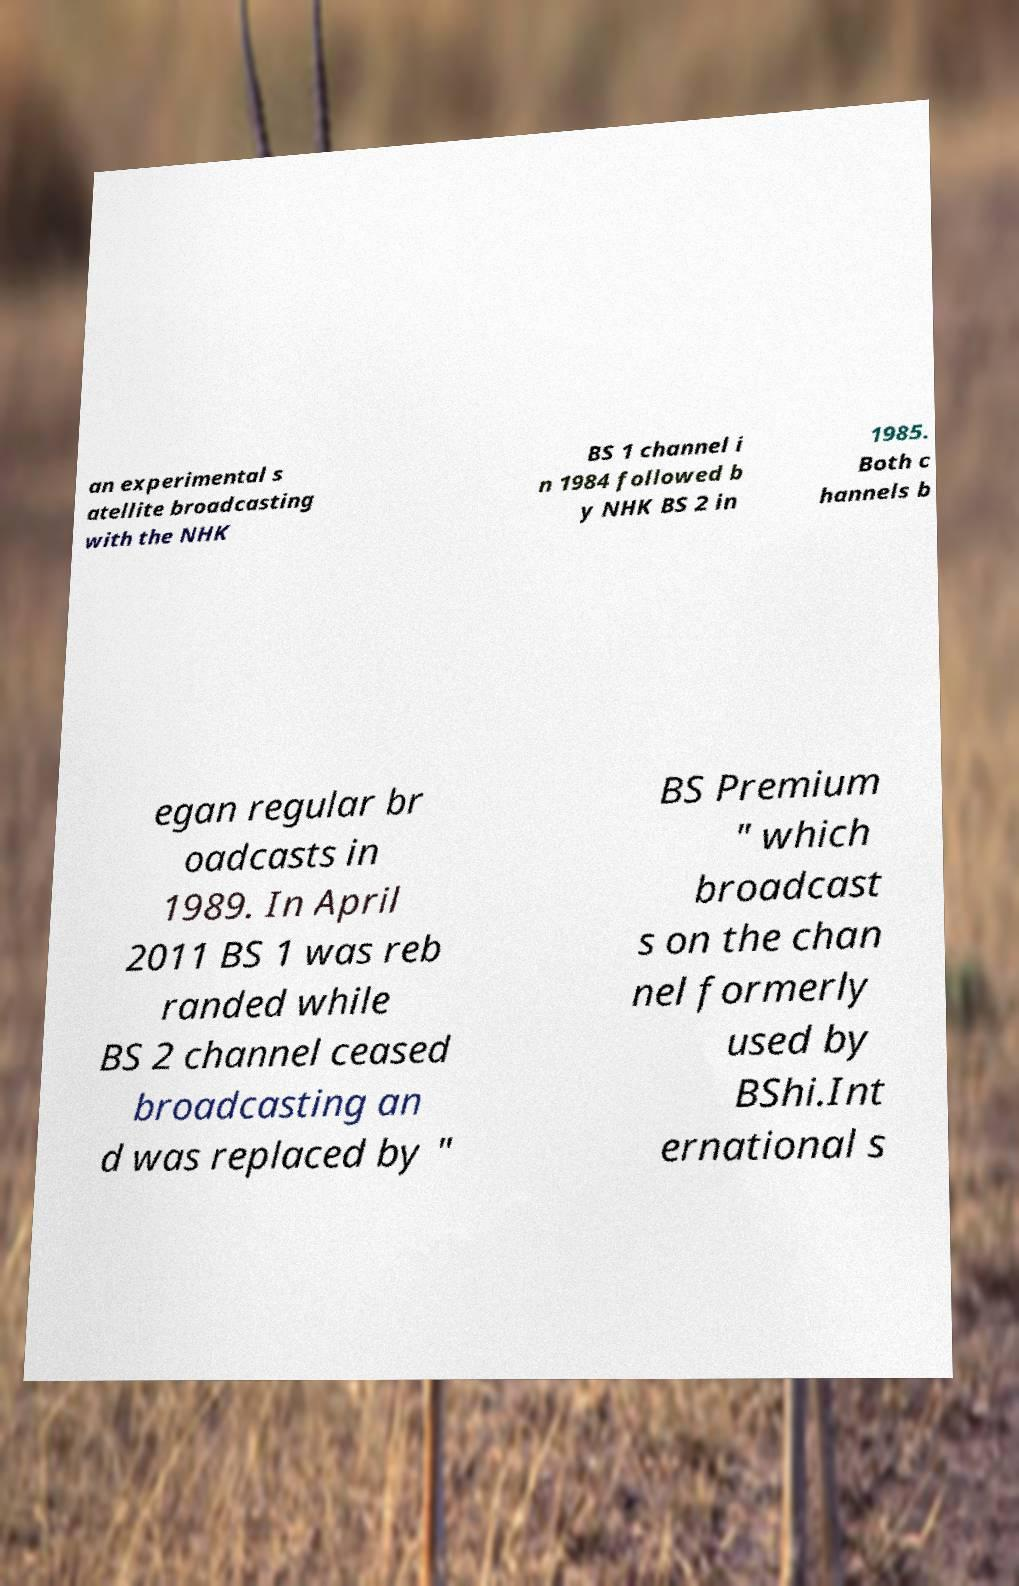Could you assist in decoding the text presented in this image and type it out clearly? an experimental s atellite broadcasting with the NHK BS 1 channel i n 1984 followed b y NHK BS 2 in 1985. Both c hannels b egan regular br oadcasts in 1989. In April 2011 BS 1 was reb randed while BS 2 channel ceased broadcasting an d was replaced by " BS Premium " which broadcast s on the chan nel formerly used by BShi.Int ernational s 